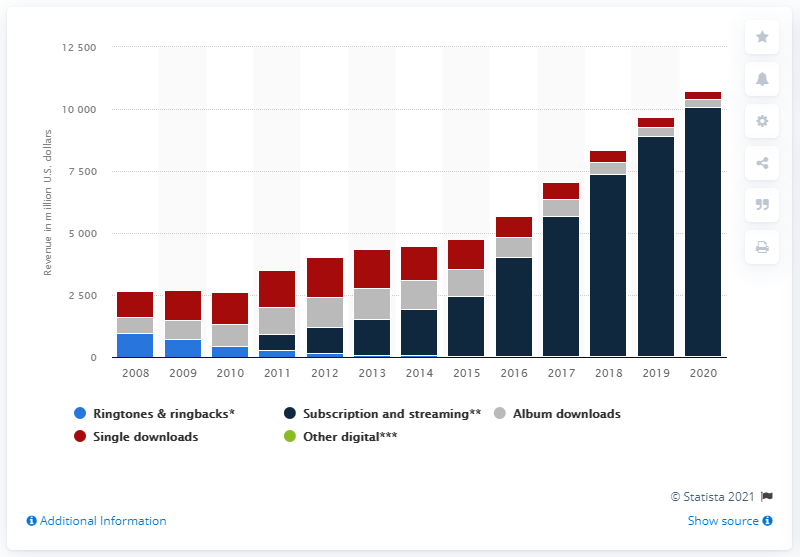Indicate a few pertinent items in this graphic. In 2020, subscription and streaming revenues reached a total of 100,74.5. In 2020, the worth of digital album downloads in dollars was approximately 319.5. 